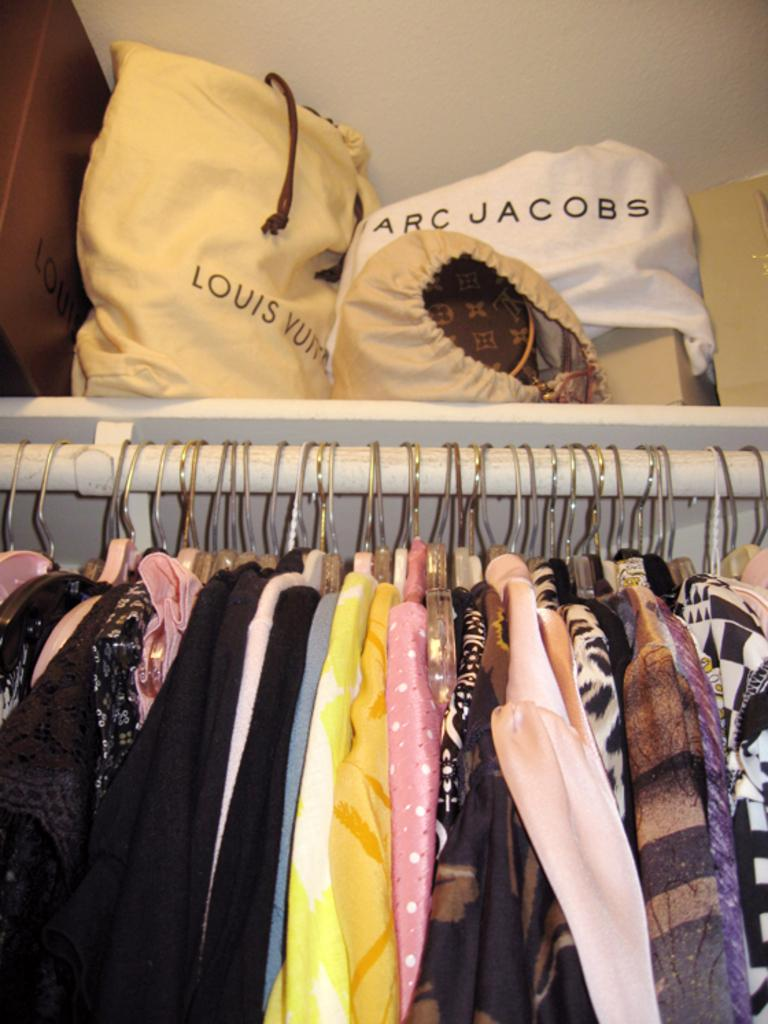What type of items can be seen in the image? There are different colored clothes and bags in the image. What is written on the bags? There is writing on the bags. Where is the cactus located in the image? There is no cactus present in the image. What type of cream is being used to clean the stove in the image? There is no stove or cream present in the image. 